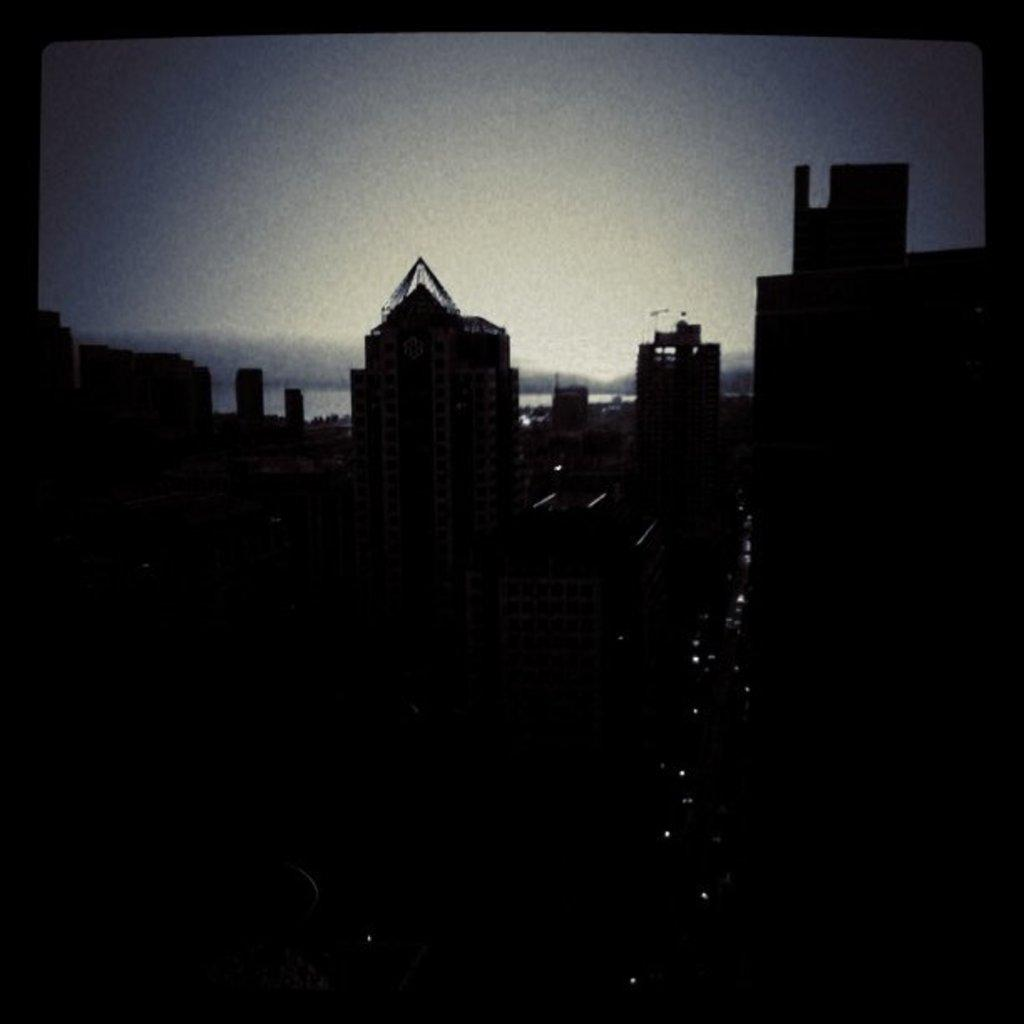What structures are located in the foreground of the image? There are buildings in the foreground of the image. What is visible at the top of the image? The sky is visible at the top of the image. What type of insurance is being discussed in the image? There is no discussion of insurance in the image; it primarily features buildings and the sky. How many times does the person in the image bite their nails? There is no person present in the image, and therefore no nail-biting can be observed. 